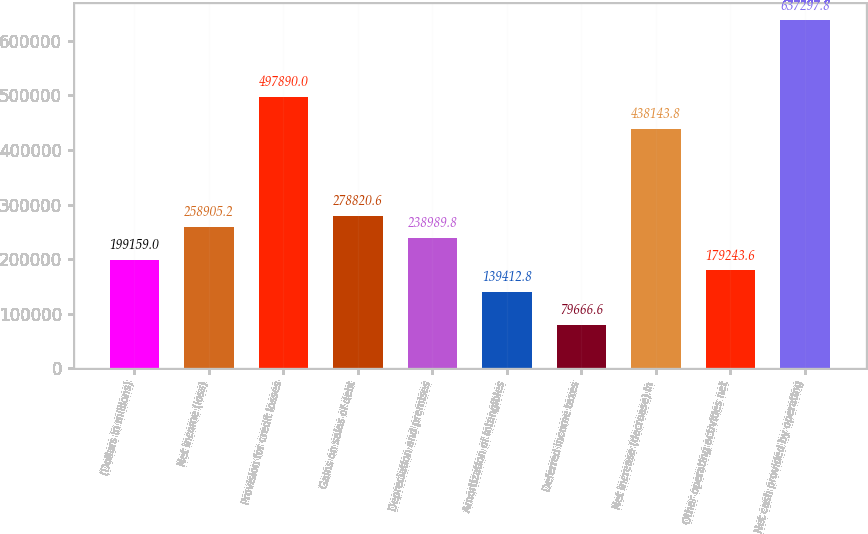Convert chart to OTSL. <chart><loc_0><loc_0><loc_500><loc_500><bar_chart><fcel>(Dollars in millions)<fcel>Net income (loss)<fcel>Provision for credit losses<fcel>Gains on sales of debt<fcel>Depreciation and premises<fcel>Amortization of intangibles<fcel>Deferred income taxes<fcel>Net increase (decrease) in<fcel>Other operating activities net<fcel>Net cash provided by operating<nl><fcel>199159<fcel>258905<fcel>497890<fcel>278821<fcel>238990<fcel>139413<fcel>79666.6<fcel>438144<fcel>179244<fcel>637298<nl></chart> 